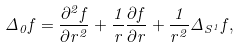<formula> <loc_0><loc_0><loc_500><loc_500>\Delta _ { 0 } f = \frac { \partial ^ { 2 } f } { \partial r ^ { 2 } } + \frac { 1 } { r } \frac { \partial f } { \partial r } + \frac { 1 } { r ^ { 2 } } \Delta _ { S ^ { 1 } } f ,</formula> 